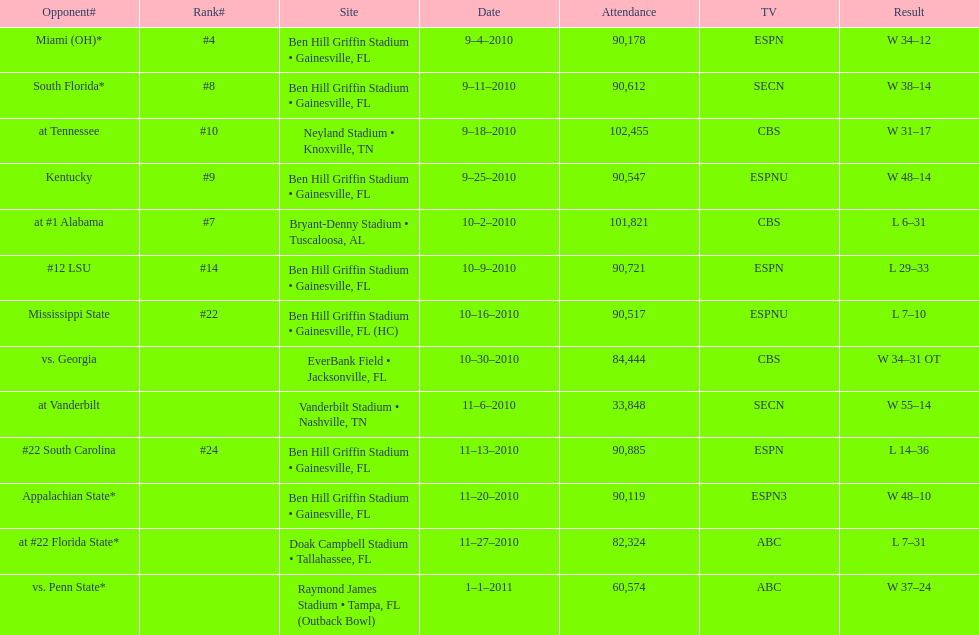What was the most the university of florida won by? 41 points. 